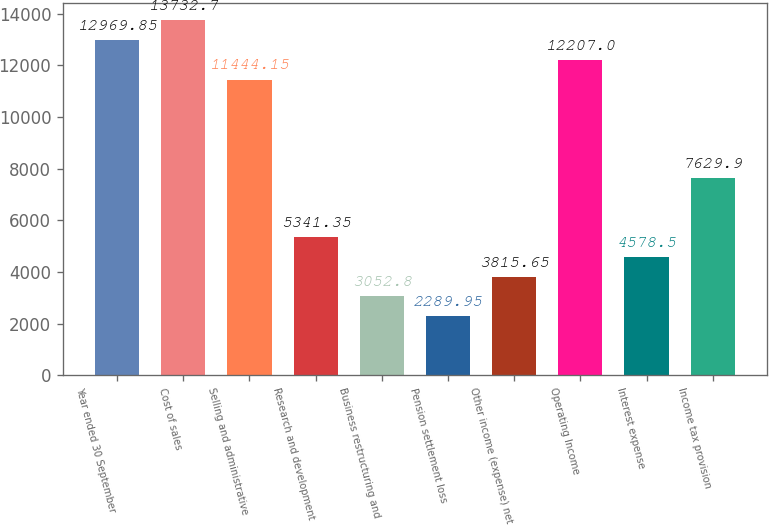Convert chart to OTSL. <chart><loc_0><loc_0><loc_500><loc_500><bar_chart><fcel>Year ended 30 September<fcel>Cost of sales<fcel>Selling and administrative<fcel>Research and development<fcel>Business restructuring and<fcel>Pension settlement loss<fcel>Other income (expense) net<fcel>Operating Income<fcel>Interest expense<fcel>Income tax provision<nl><fcel>12969.9<fcel>13732.7<fcel>11444.1<fcel>5341.35<fcel>3052.8<fcel>2289.95<fcel>3815.65<fcel>12207<fcel>4578.5<fcel>7629.9<nl></chart> 